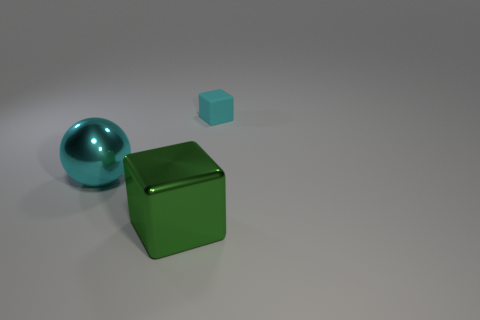Add 2 green metallic cubes. How many objects exist? 5 Subtract 1 cyan blocks. How many objects are left? 2 Subtract all blocks. How many objects are left? 1 Subtract all yellow spheres. Subtract all red cylinders. How many spheres are left? 1 Subtract all large brown matte spheres. Subtract all tiny cyan cubes. How many objects are left? 2 Add 2 tiny cyan cubes. How many tiny cyan cubes are left? 3 Add 2 large brown cubes. How many large brown cubes exist? 2 